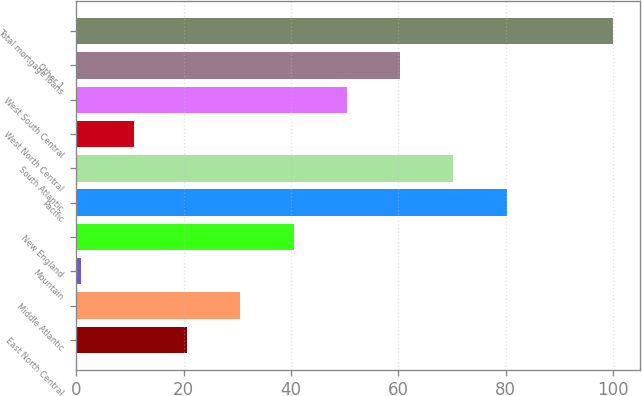Convert chart. <chart><loc_0><loc_0><loc_500><loc_500><bar_chart><fcel>East North Central<fcel>Middle Atlantic<fcel>Mountain<fcel>New England<fcel>Pacific<fcel>South Atlantic<fcel>West North Central<fcel>West South Central<fcel>Other 1<fcel>Total mortgage loans<nl><fcel>20.64<fcel>30.56<fcel>0.8<fcel>40.48<fcel>80.16<fcel>70.24<fcel>10.72<fcel>50.4<fcel>60.32<fcel>100<nl></chart> 